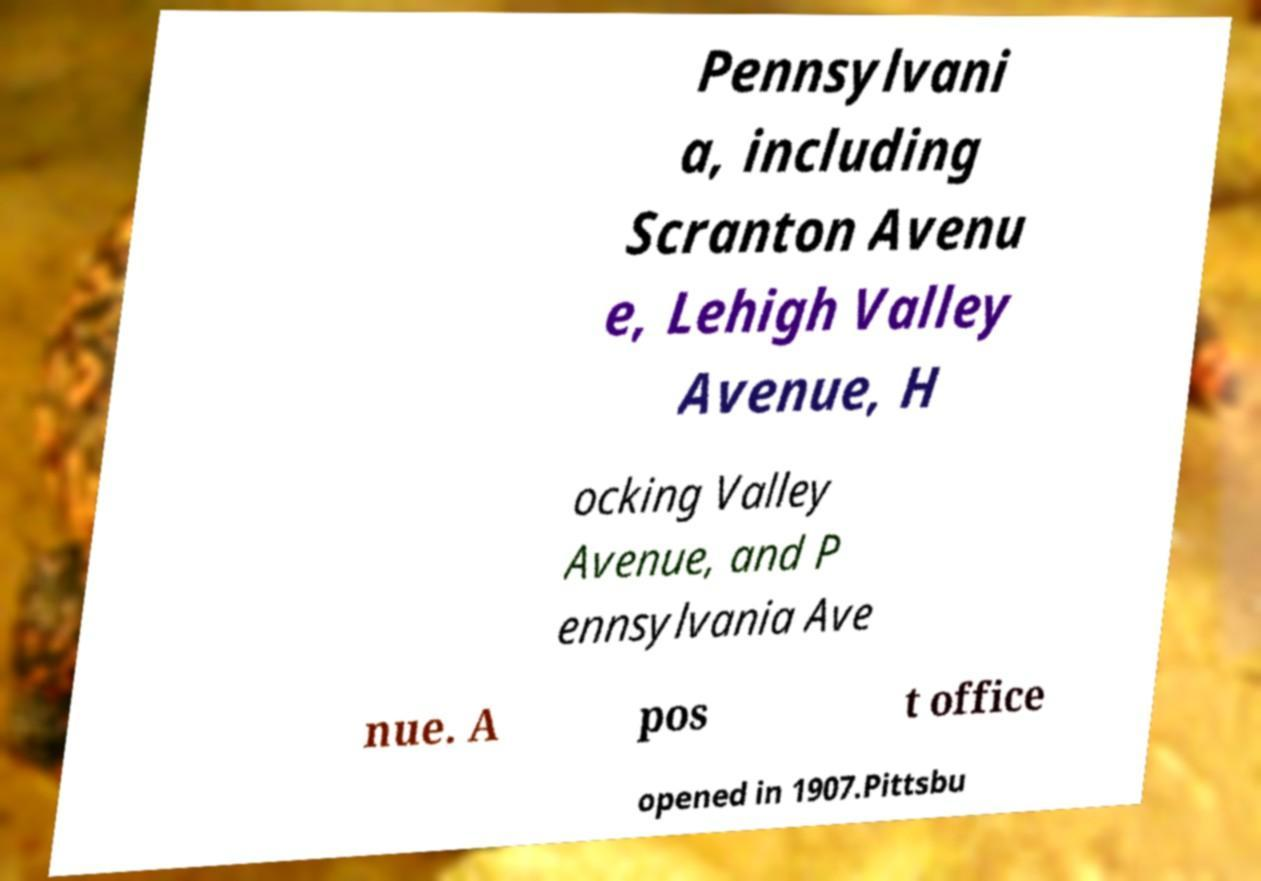There's text embedded in this image that I need extracted. Can you transcribe it verbatim? Pennsylvani a, including Scranton Avenu e, Lehigh Valley Avenue, H ocking Valley Avenue, and P ennsylvania Ave nue. A pos t office opened in 1907.Pittsbu 